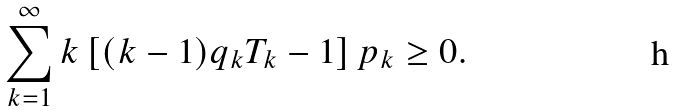<formula> <loc_0><loc_0><loc_500><loc_500>\sum _ { k = 1 } ^ { \infty } k \left [ ( k - 1 ) q _ { k } T _ { k } - 1 \right ] p _ { k } \geq 0 .</formula> 